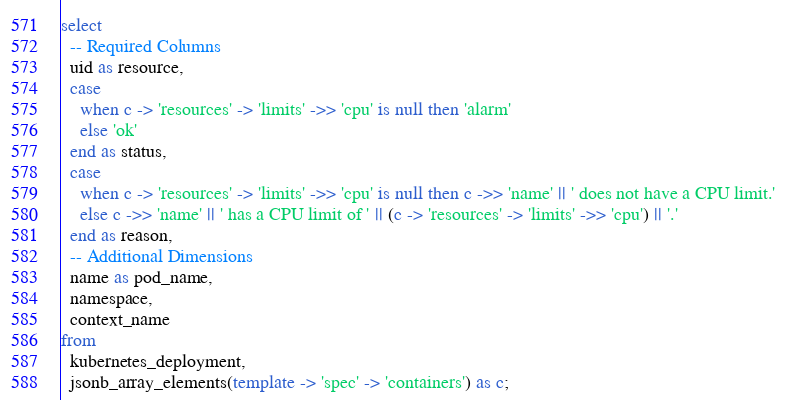<code> <loc_0><loc_0><loc_500><loc_500><_SQL_>select
  -- Required Columns
  uid as resource,
  case
    when c -> 'resources' -> 'limits' ->> 'cpu' is null then 'alarm'
    else 'ok'
  end as status,
  case
    when c -> 'resources' -> 'limits' ->> 'cpu' is null then c ->> 'name' || ' does not have a CPU limit.'
    else c ->> 'name' || ' has a CPU limit of ' || (c -> 'resources' -> 'limits' ->> 'cpu') || '.'
  end as reason,
  -- Additional Dimensions
  name as pod_name,
  namespace,
  context_name
from
  kubernetes_deployment,
  jsonb_array_elements(template -> 'spec' -> 'containers') as c;</code> 